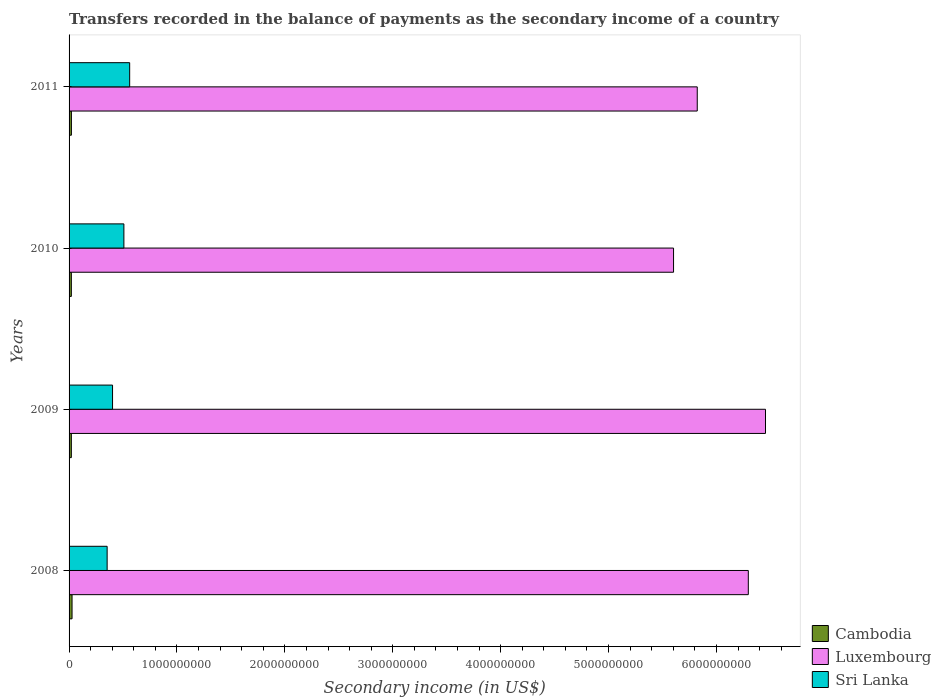How many different coloured bars are there?
Ensure brevity in your answer.  3. How many groups of bars are there?
Offer a very short reply. 4. How many bars are there on the 3rd tick from the top?
Ensure brevity in your answer.  3. In how many cases, is the number of bars for a given year not equal to the number of legend labels?
Your answer should be very brief. 0. What is the secondary income of in Sri Lanka in 2008?
Make the answer very short. 3.53e+08. Across all years, what is the maximum secondary income of in Sri Lanka?
Keep it short and to the point. 5.62e+08. Across all years, what is the minimum secondary income of in Cambodia?
Offer a very short reply. 2.11e+07. What is the total secondary income of in Luxembourg in the graph?
Your response must be concise. 2.42e+1. What is the difference between the secondary income of in Luxembourg in 2008 and that in 2009?
Make the answer very short. -1.59e+08. What is the difference between the secondary income of in Sri Lanka in 2009 and the secondary income of in Cambodia in 2011?
Ensure brevity in your answer.  3.81e+08. What is the average secondary income of in Luxembourg per year?
Give a very brief answer. 6.04e+09. In the year 2011, what is the difference between the secondary income of in Sri Lanka and secondary income of in Luxembourg?
Provide a short and direct response. -5.26e+09. What is the ratio of the secondary income of in Cambodia in 2010 to that in 2011?
Keep it short and to the point. 0.98. What is the difference between the highest and the second highest secondary income of in Cambodia?
Ensure brevity in your answer.  6.04e+06. What is the difference between the highest and the lowest secondary income of in Cambodia?
Offer a terse response. 6.55e+06. Is the sum of the secondary income of in Sri Lanka in 2010 and 2011 greater than the maximum secondary income of in Luxembourg across all years?
Ensure brevity in your answer.  No. What does the 2nd bar from the top in 2009 represents?
Offer a terse response. Luxembourg. What does the 3rd bar from the bottom in 2009 represents?
Ensure brevity in your answer.  Sri Lanka. Is it the case that in every year, the sum of the secondary income of in Sri Lanka and secondary income of in Cambodia is greater than the secondary income of in Luxembourg?
Your answer should be compact. No. Does the graph contain grids?
Provide a short and direct response. No. How are the legend labels stacked?
Ensure brevity in your answer.  Vertical. What is the title of the graph?
Your answer should be compact. Transfers recorded in the balance of payments as the secondary income of a country. Does "Latin America(developing only)" appear as one of the legend labels in the graph?
Your response must be concise. No. What is the label or title of the X-axis?
Keep it short and to the point. Secondary income (in US$). What is the Secondary income (in US$) of Cambodia in 2008?
Provide a succinct answer. 2.76e+07. What is the Secondary income (in US$) in Luxembourg in 2008?
Ensure brevity in your answer.  6.30e+09. What is the Secondary income (in US$) of Sri Lanka in 2008?
Provide a short and direct response. 3.53e+08. What is the Secondary income (in US$) of Cambodia in 2009?
Your response must be concise. 2.11e+07. What is the Secondary income (in US$) in Luxembourg in 2009?
Provide a short and direct response. 6.45e+09. What is the Secondary income (in US$) in Sri Lanka in 2009?
Ensure brevity in your answer.  4.03e+08. What is the Secondary income (in US$) of Cambodia in 2010?
Your answer should be compact. 2.11e+07. What is the Secondary income (in US$) of Luxembourg in 2010?
Provide a succinct answer. 5.60e+09. What is the Secondary income (in US$) in Sri Lanka in 2010?
Ensure brevity in your answer.  5.08e+08. What is the Secondary income (in US$) of Cambodia in 2011?
Your response must be concise. 2.16e+07. What is the Secondary income (in US$) of Luxembourg in 2011?
Provide a succinct answer. 5.82e+09. What is the Secondary income (in US$) in Sri Lanka in 2011?
Provide a short and direct response. 5.62e+08. Across all years, what is the maximum Secondary income (in US$) of Cambodia?
Give a very brief answer. 2.76e+07. Across all years, what is the maximum Secondary income (in US$) of Luxembourg?
Ensure brevity in your answer.  6.45e+09. Across all years, what is the maximum Secondary income (in US$) in Sri Lanka?
Provide a short and direct response. 5.62e+08. Across all years, what is the minimum Secondary income (in US$) in Cambodia?
Keep it short and to the point. 2.11e+07. Across all years, what is the minimum Secondary income (in US$) in Luxembourg?
Ensure brevity in your answer.  5.60e+09. Across all years, what is the minimum Secondary income (in US$) in Sri Lanka?
Offer a terse response. 3.53e+08. What is the total Secondary income (in US$) in Cambodia in the graph?
Your answer should be compact. 9.15e+07. What is the total Secondary income (in US$) of Luxembourg in the graph?
Make the answer very short. 2.42e+1. What is the total Secondary income (in US$) in Sri Lanka in the graph?
Keep it short and to the point. 1.83e+09. What is the difference between the Secondary income (in US$) of Cambodia in 2008 and that in 2009?
Provide a succinct answer. 6.55e+06. What is the difference between the Secondary income (in US$) in Luxembourg in 2008 and that in 2009?
Offer a terse response. -1.59e+08. What is the difference between the Secondary income (in US$) of Sri Lanka in 2008 and that in 2009?
Ensure brevity in your answer.  -5.02e+07. What is the difference between the Secondary income (in US$) in Cambodia in 2008 and that in 2010?
Your response must be concise. 6.52e+06. What is the difference between the Secondary income (in US$) in Luxembourg in 2008 and that in 2010?
Keep it short and to the point. 6.93e+08. What is the difference between the Secondary income (in US$) of Sri Lanka in 2008 and that in 2010?
Keep it short and to the point. -1.55e+08. What is the difference between the Secondary income (in US$) of Cambodia in 2008 and that in 2011?
Offer a very short reply. 6.04e+06. What is the difference between the Secondary income (in US$) of Luxembourg in 2008 and that in 2011?
Your response must be concise. 4.73e+08. What is the difference between the Secondary income (in US$) of Sri Lanka in 2008 and that in 2011?
Your answer should be very brief. -2.09e+08. What is the difference between the Secondary income (in US$) of Cambodia in 2009 and that in 2010?
Make the answer very short. -2.60e+04. What is the difference between the Secondary income (in US$) of Luxembourg in 2009 and that in 2010?
Your answer should be very brief. 8.52e+08. What is the difference between the Secondary income (in US$) of Sri Lanka in 2009 and that in 2010?
Make the answer very short. -1.05e+08. What is the difference between the Secondary income (in US$) in Cambodia in 2009 and that in 2011?
Make the answer very short. -5.15e+05. What is the difference between the Secondary income (in US$) in Luxembourg in 2009 and that in 2011?
Offer a terse response. 6.33e+08. What is the difference between the Secondary income (in US$) in Sri Lanka in 2009 and that in 2011?
Provide a succinct answer. -1.59e+08. What is the difference between the Secondary income (in US$) of Cambodia in 2010 and that in 2011?
Keep it short and to the point. -4.89e+05. What is the difference between the Secondary income (in US$) in Luxembourg in 2010 and that in 2011?
Provide a short and direct response. -2.20e+08. What is the difference between the Secondary income (in US$) in Sri Lanka in 2010 and that in 2011?
Offer a very short reply. -5.36e+07. What is the difference between the Secondary income (in US$) in Cambodia in 2008 and the Secondary income (in US$) in Luxembourg in 2009?
Make the answer very short. -6.43e+09. What is the difference between the Secondary income (in US$) in Cambodia in 2008 and the Secondary income (in US$) in Sri Lanka in 2009?
Keep it short and to the point. -3.75e+08. What is the difference between the Secondary income (in US$) in Luxembourg in 2008 and the Secondary income (in US$) in Sri Lanka in 2009?
Offer a terse response. 5.89e+09. What is the difference between the Secondary income (in US$) of Cambodia in 2008 and the Secondary income (in US$) of Luxembourg in 2010?
Your response must be concise. -5.57e+09. What is the difference between the Secondary income (in US$) of Cambodia in 2008 and the Secondary income (in US$) of Sri Lanka in 2010?
Provide a short and direct response. -4.80e+08. What is the difference between the Secondary income (in US$) of Luxembourg in 2008 and the Secondary income (in US$) of Sri Lanka in 2010?
Provide a succinct answer. 5.79e+09. What is the difference between the Secondary income (in US$) of Cambodia in 2008 and the Secondary income (in US$) of Luxembourg in 2011?
Ensure brevity in your answer.  -5.79e+09. What is the difference between the Secondary income (in US$) of Cambodia in 2008 and the Secondary income (in US$) of Sri Lanka in 2011?
Offer a terse response. -5.34e+08. What is the difference between the Secondary income (in US$) of Luxembourg in 2008 and the Secondary income (in US$) of Sri Lanka in 2011?
Provide a short and direct response. 5.73e+09. What is the difference between the Secondary income (in US$) in Cambodia in 2009 and the Secondary income (in US$) in Luxembourg in 2010?
Your answer should be very brief. -5.58e+09. What is the difference between the Secondary income (in US$) in Cambodia in 2009 and the Secondary income (in US$) in Sri Lanka in 2010?
Give a very brief answer. -4.87e+08. What is the difference between the Secondary income (in US$) in Luxembourg in 2009 and the Secondary income (in US$) in Sri Lanka in 2010?
Ensure brevity in your answer.  5.95e+09. What is the difference between the Secondary income (in US$) in Cambodia in 2009 and the Secondary income (in US$) in Luxembourg in 2011?
Offer a very short reply. -5.80e+09. What is the difference between the Secondary income (in US$) in Cambodia in 2009 and the Secondary income (in US$) in Sri Lanka in 2011?
Your answer should be very brief. -5.41e+08. What is the difference between the Secondary income (in US$) of Luxembourg in 2009 and the Secondary income (in US$) of Sri Lanka in 2011?
Ensure brevity in your answer.  5.89e+09. What is the difference between the Secondary income (in US$) in Cambodia in 2010 and the Secondary income (in US$) in Luxembourg in 2011?
Provide a succinct answer. -5.80e+09. What is the difference between the Secondary income (in US$) in Cambodia in 2010 and the Secondary income (in US$) in Sri Lanka in 2011?
Keep it short and to the point. -5.41e+08. What is the difference between the Secondary income (in US$) in Luxembourg in 2010 and the Secondary income (in US$) in Sri Lanka in 2011?
Make the answer very short. 5.04e+09. What is the average Secondary income (in US$) of Cambodia per year?
Provide a short and direct response. 2.29e+07. What is the average Secondary income (in US$) in Luxembourg per year?
Make the answer very short. 6.04e+09. What is the average Secondary income (in US$) in Sri Lanka per year?
Offer a terse response. 4.56e+08. In the year 2008, what is the difference between the Secondary income (in US$) in Cambodia and Secondary income (in US$) in Luxembourg?
Make the answer very short. -6.27e+09. In the year 2008, what is the difference between the Secondary income (in US$) of Cambodia and Secondary income (in US$) of Sri Lanka?
Give a very brief answer. -3.25e+08. In the year 2008, what is the difference between the Secondary income (in US$) in Luxembourg and Secondary income (in US$) in Sri Lanka?
Keep it short and to the point. 5.94e+09. In the year 2009, what is the difference between the Secondary income (in US$) in Cambodia and Secondary income (in US$) in Luxembourg?
Keep it short and to the point. -6.43e+09. In the year 2009, what is the difference between the Secondary income (in US$) of Cambodia and Secondary income (in US$) of Sri Lanka?
Give a very brief answer. -3.82e+08. In the year 2009, what is the difference between the Secondary income (in US$) in Luxembourg and Secondary income (in US$) in Sri Lanka?
Offer a terse response. 6.05e+09. In the year 2010, what is the difference between the Secondary income (in US$) of Cambodia and Secondary income (in US$) of Luxembourg?
Provide a succinct answer. -5.58e+09. In the year 2010, what is the difference between the Secondary income (in US$) in Cambodia and Secondary income (in US$) in Sri Lanka?
Offer a terse response. -4.87e+08. In the year 2010, what is the difference between the Secondary income (in US$) of Luxembourg and Secondary income (in US$) of Sri Lanka?
Offer a terse response. 5.09e+09. In the year 2011, what is the difference between the Secondary income (in US$) in Cambodia and Secondary income (in US$) in Luxembourg?
Your answer should be compact. -5.80e+09. In the year 2011, what is the difference between the Secondary income (in US$) in Cambodia and Secondary income (in US$) in Sri Lanka?
Offer a very short reply. -5.40e+08. In the year 2011, what is the difference between the Secondary income (in US$) of Luxembourg and Secondary income (in US$) of Sri Lanka?
Your answer should be very brief. 5.26e+09. What is the ratio of the Secondary income (in US$) in Cambodia in 2008 to that in 2009?
Make the answer very short. 1.31. What is the ratio of the Secondary income (in US$) of Luxembourg in 2008 to that in 2009?
Keep it short and to the point. 0.98. What is the ratio of the Secondary income (in US$) of Sri Lanka in 2008 to that in 2009?
Provide a short and direct response. 0.88. What is the ratio of the Secondary income (in US$) of Cambodia in 2008 to that in 2010?
Provide a succinct answer. 1.31. What is the ratio of the Secondary income (in US$) of Luxembourg in 2008 to that in 2010?
Provide a short and direct response. 1.12. What is the ratio of the Secondary income (in US$) in Sri Lanka in 2008 to that in 2010?
Keep it short and to the point. 0.69. What is the ratio of the Secondary income (in US$) in Cambodia in 2008 to that in 2011?
Your answer should be very brief. 1.28. What is the ratio of the Secondary income (in US$) of Luxembourg in 2008 to that in 2011?
Your answer should be compact. 1.08. What is the ratio of the Secondary income (in US$) in Sri Lanka in 2008 to that in 2011?
Ensure brevity in your answer.  0.63. What is the ratio of the Secondary income (in US$) of Cambodia in 2009 to that in 2010?
Keep it short and to the point. 1. What is the ratio of the Secondary income (in US$) in Luxembourg in 2009 to that in 2010?
Your answer should be compact. 1.15. What is the ratio of the Secondary income (in US$) of Sri Lanka in 2009 to that in 2010?
Your response must be concise. 0.79. What is the ratio of the Secondary income (in US$) in Cambodia in 2009 to that in 2011?
Your answer should be very brief. 0.98. What is the ratio of the Secondary income (in US$) in Luxembourg in 2009 to that in 2011?
Give a very brief answer. 1.11. What is the ratio of the Secondary income (in US$) of Sri Lanka in 2009 to that in 2011?
Offer a terse response. 0.72. What is the ratio of the Secondary income (in US$) in Cambodia in 2010 to that in 2011?
Your answer should be very brief. 0.98. What is the ratio of the Secondary income (in US$) of Luxembourg in 2010 to that in 2011?
Your answer should be compact. 0.96. What is the ratio of the Secondary income (in US$) of Sri Lanka in 2010 to that in 2011?
Make the answer very short. 0.9. What is the difference between the highest and the second highest Secondary income (in US$) of Cambodia?
Give a very brief answer. 6.04e+06. What is the difference between the highest and the second highest Secondary income (in US$) in Luxembourg?
Offer a terse response. 1.59e+08. What is the difference between the highest and the second highest Secondary income (in US$) of Sri Lanka?
Ensure brevity in your answer.  5.36e+07. What is the difference between the highest and the lowest Secondary income (in US$) of Cambodia?
Give a very brief answer. 6.55e+06. What is the difference between the highest and the lowest Secondary income (in US$) of Luxembourg?
Make the answer very short. 8.52e+08. What is the difference between the highest and the lowest Secondary income (in US$) in Sri Lanka?
Give a very brief answer. 2.09e+08. 